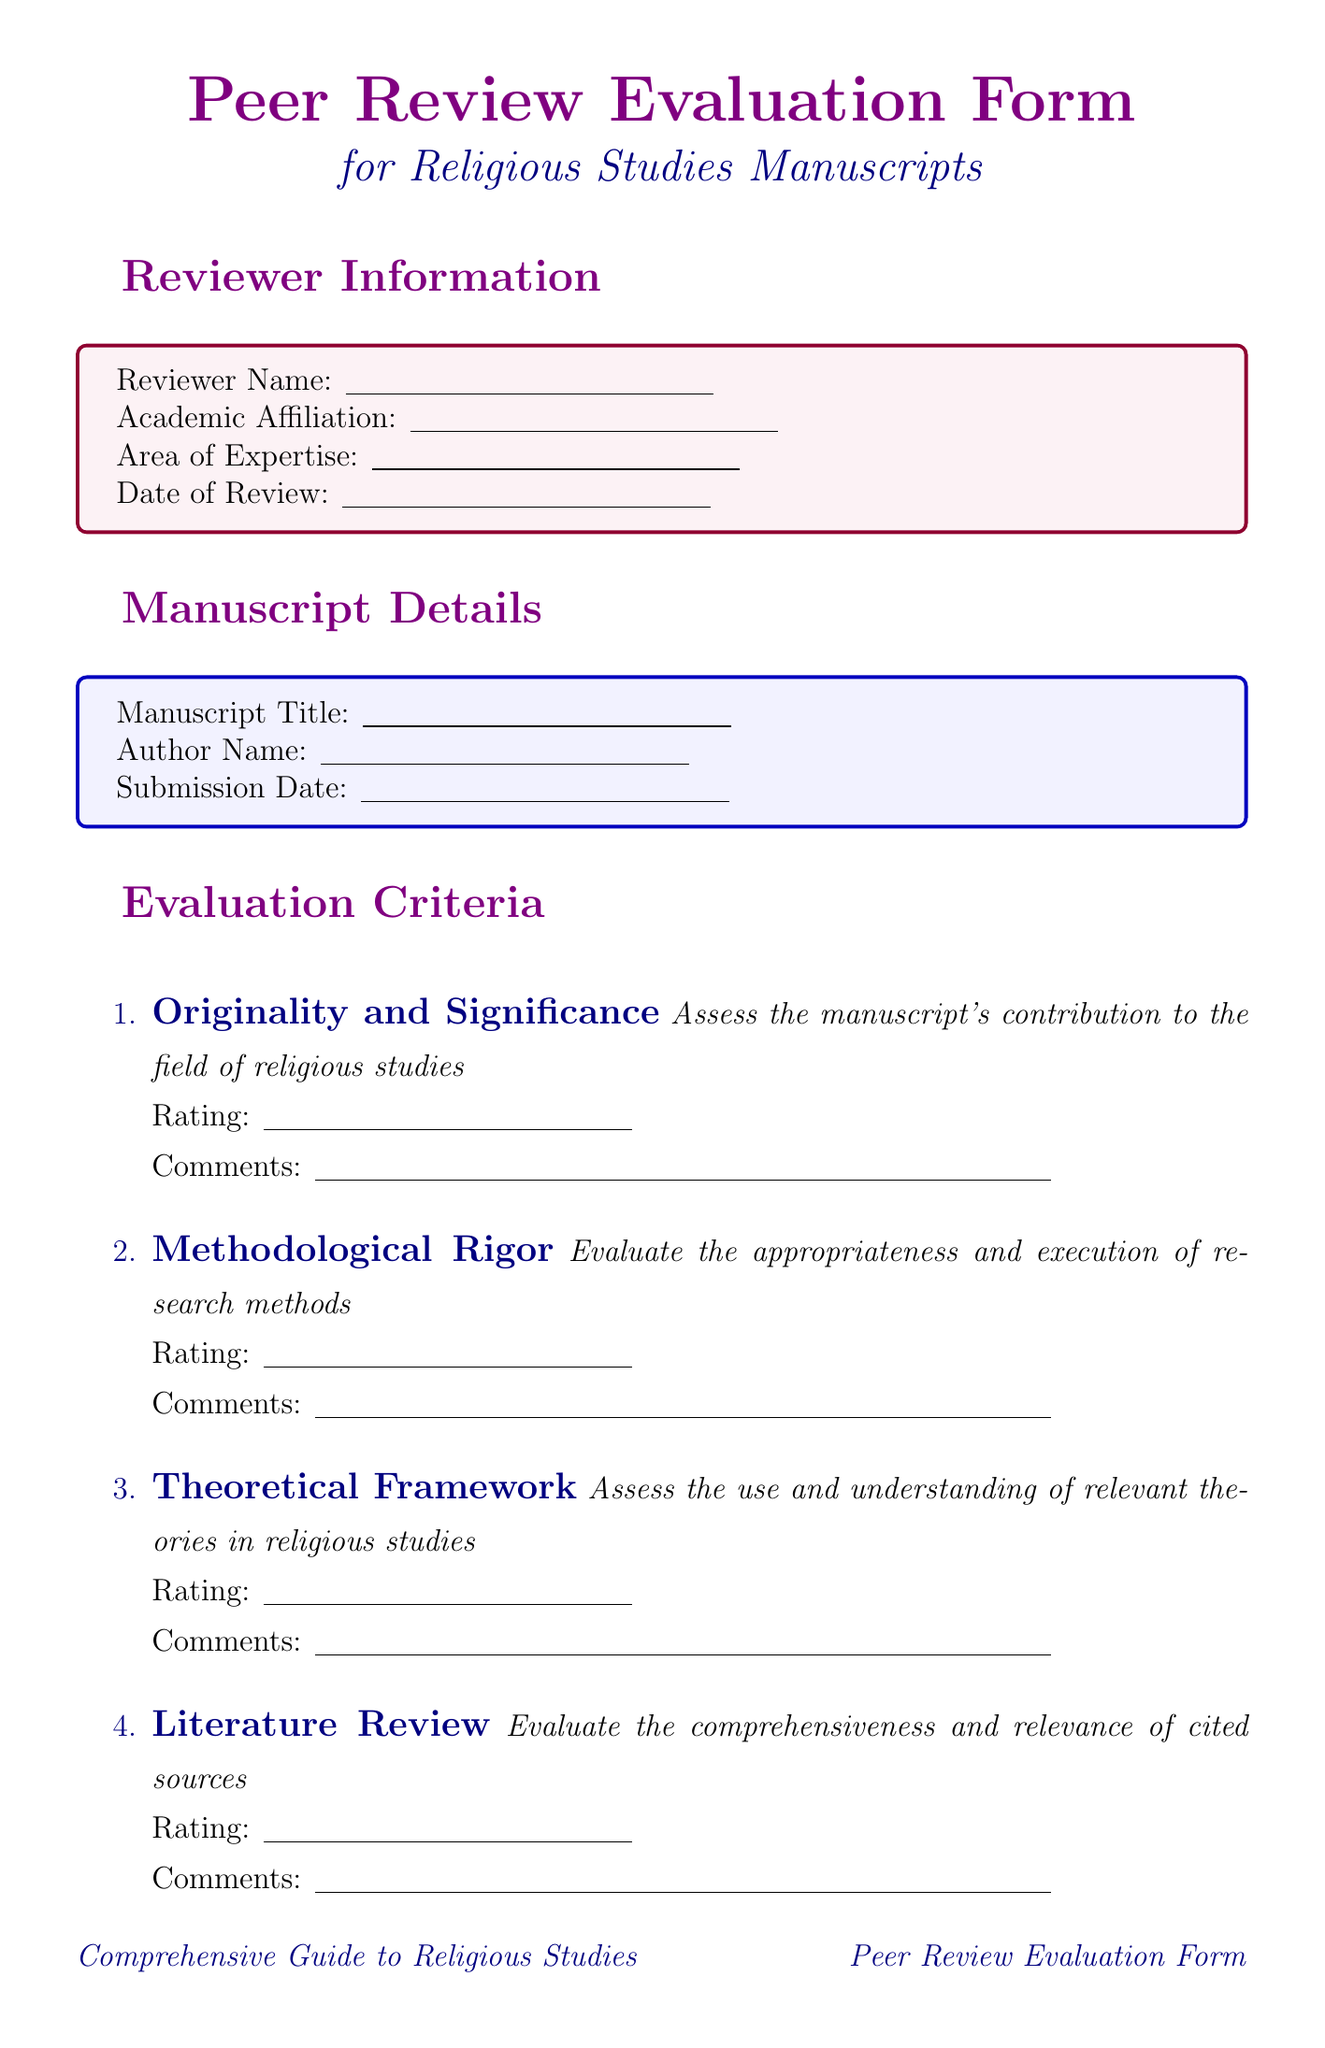What is the title of the form? The title of the form is stated prominently at the top of the document, indicating its purpose regarding peer review.
Answer: Peer Review Evaluation Form for Religious Studies Manuscripts What is the area of expertise of the reviewer? This section is included in the reviewer information, allowing the reviewer to specify their qualifications.
Answer: (to be filled by the reviewer) What is the submission date of the manuscript? The submission date is provided in the manuscript details section where the author can specify the date they submitted their work.
Answer: (to be filled by the author) What is the highest rating on the originality and significance criterion? The rating scale for each criterion includes a maximum score that assesses the excellent quality of the manuscript's contribution.
Answer: 5 - Excellent What are the recommended options in the overall assessment? The overall assessment section lists options available for the reviewer's recommendation regarding the manuscript's acceptance.
Answer: Accept as is, Accept with minor revisions, Accept with major revisions, Reject and encourage resubmission, Reject How many evaluation criteria are listed in the form? The document details a list of assessment points that evaluate the manuscript's quality across various domains.
Answer: 6 Does the document include a section for suggested revisions? This section allows the reviewer to provide recommendations specifically related to parts of the manuscript needing improvement.
Answer: Yes Are there any journals listed as relevant in the document? The relevant journals section lists specific publications that the manuscript might be suitable for, indicating its academic context.
Answer: Yes What is the purpose of the additional questions section? This section is designed to gather supplemental insights from the reviewer on specific important aspects of the manuscript.
Answer: To assess specific issues related to the manuscript 